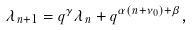Convert formula to latex. <formula><loc_0><loc_0><loc_500><loc_500>\lambda _ { n + 1 } = q ^ { \gamma } \lambda _ { n } + q ^ { \alpha ( n + \nu _ { 0 } ) + \beta } ,</formula> 